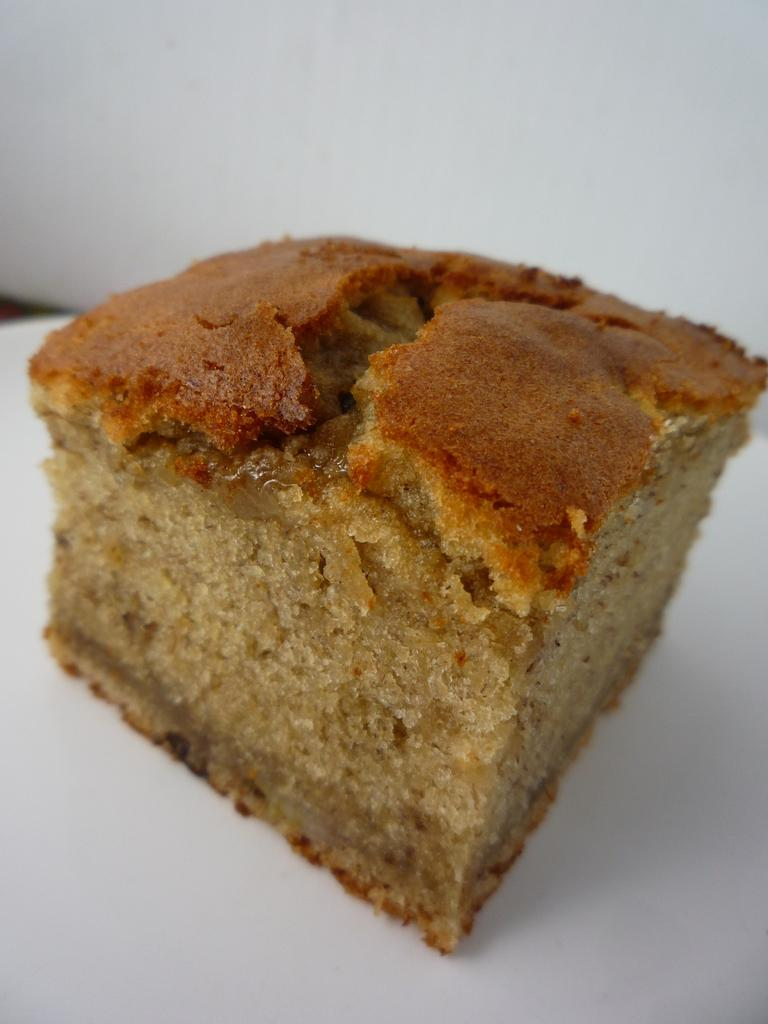What is the main subject in the foreground of the image? There is a cake on a platter in the foreground of the image. What can be seen in the background of the image? There is a white wall in the background of the image. What type of cracker is being used to mark the territory of the cake in the image? There is no cracker or indication of territory in the image; it simply features a cake on a platter and a white wall in the background. 